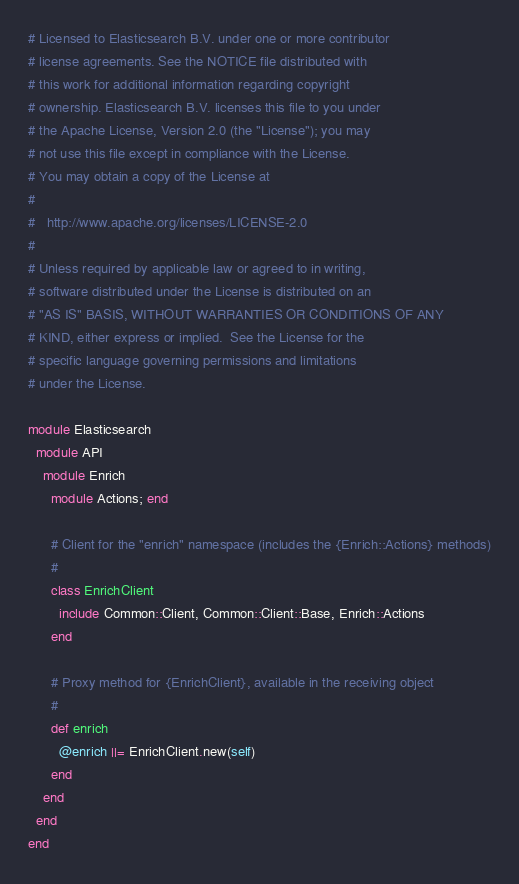Convert code to text. <code><loc_0><loc_0><loc_500><loc_500><_Ruby_># Licensed to Elasticsearch B.V. under one or more contributor
# license agreements. See the NOTICE file distributed with
# this work for additional information regarding copyright
# ownership. Elasticsearch B.V. licenses this file to you under
# the Apache License, Version 2.0 (the "License"); you may
# not use this file except in compliance with the License.
# You may obtain a copy of the License at
#
#   http://www.apache.org/licenses/LICENSE-2.0
#
# Unless required by applicable law or agreed to in writing,
# software distributed under the License is distributed on an
# "AS IS" BASIS, WITHOUT WARRANTIES OR CONDITIONS OF ANY
# KIND, either express or implied.  See the License for the
# specific language governing permissions and limitations
# under the License.

module Elasticsearch
  module API
    module Enrich
      module Actions; end

      # Client for the "enrich" namespace (includes the {Enrich::Actions} methods)
      #
      class EnrichClient
        include Common::Client, Common::Client::Base, Enrich::Actions
      end

      # Proxy method for {EnrichClient}, available in the receiving object
      #
      def enrich
        @enrich ||= EnrichClient.new(self)
      end
    end
  end
end
</code> 